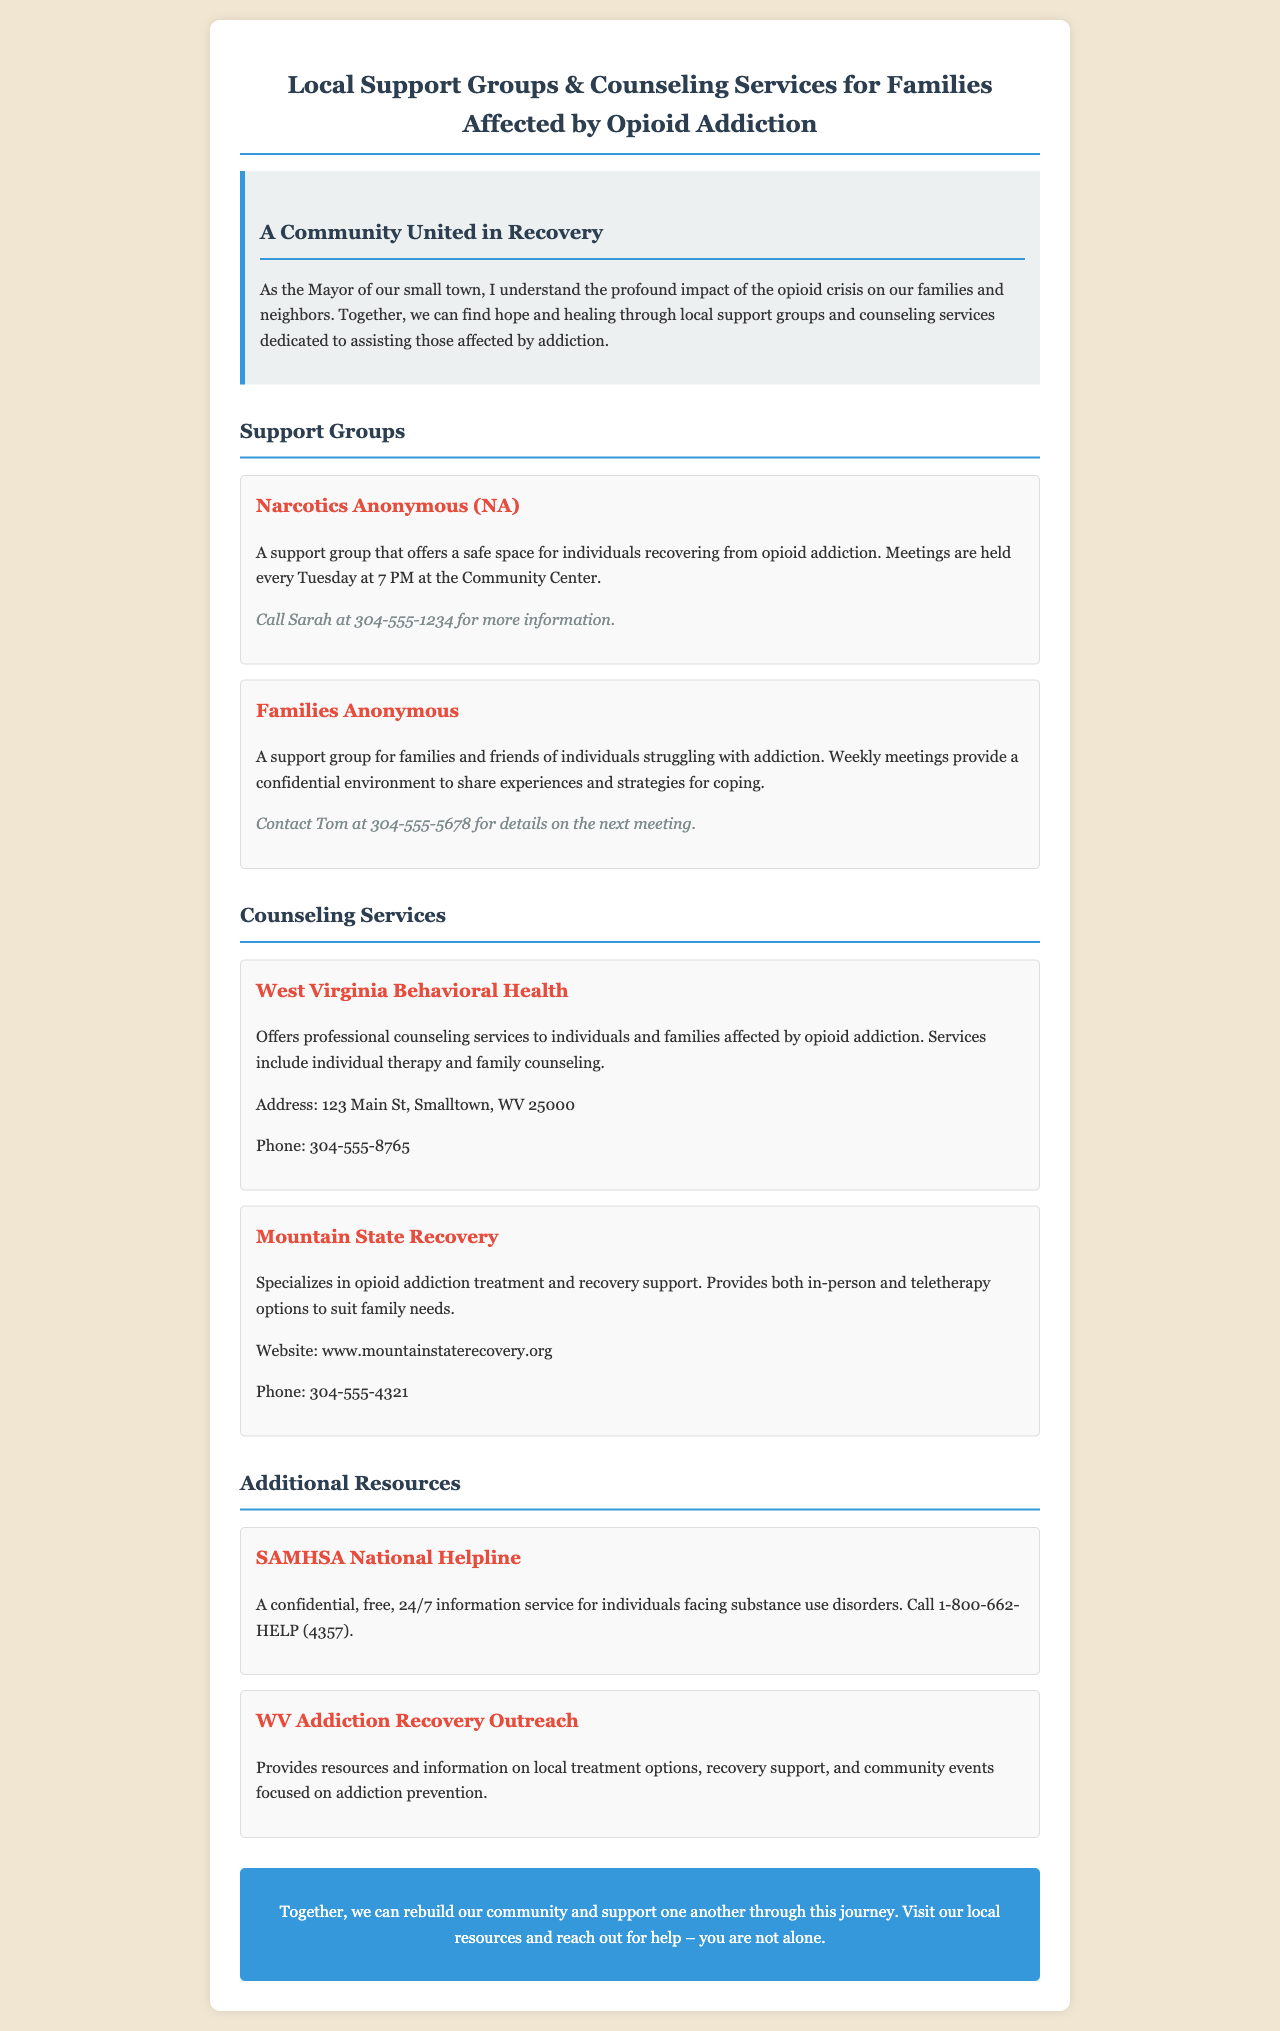What support group meets every Tuesday? The document states that Narcotics Anonymous (NA) holds meetings every Tuesday at 7 PM.
Answer: Narcotics Anonymous (NA) Who do I contact for Families Anonymous? Tom's contact information is provided for Families Anonymous in the document.
Answer: Tom at 304-555-5678 What is the address of West Virginia Behavioral Health? The document specifies the address for West Virginia Behavioral Health as part of its contact details.
Answer: 123 Main St, Smalltown, WV 25000 What type of therapy does Mountain State Recovery provide? The document mentions that Mountain State Recovery offers in-person and teletherapy options for families.
Answer: In-person and teletherapy What is the phone number for West Virginia Behavioral Health? The phone number for West Virginia Behavioral Health is listed in the document.
Answer: 304-555-8765 How often does Families Anonymous meet? The document indicates that Families Anonymous has weekly meetings.
Answer: Weekly What is the purpose of the SAMHSA National Helpline? The document describes the SAMHSA National Helpline as a confidential service for individuals facing substance use disorders.
Answer: Information service Who is the target audience for the counseling services mentioned? The document notes that the counseling services are for individuals and families affected by opioid addiction.
Answer: Individuals and families affected by opioid addiction What is the website for Mountain State Recovery? The document lists the website for Mountain State Recovery as part of its contact information.
Answer: www.mountainstaterecovery.org 